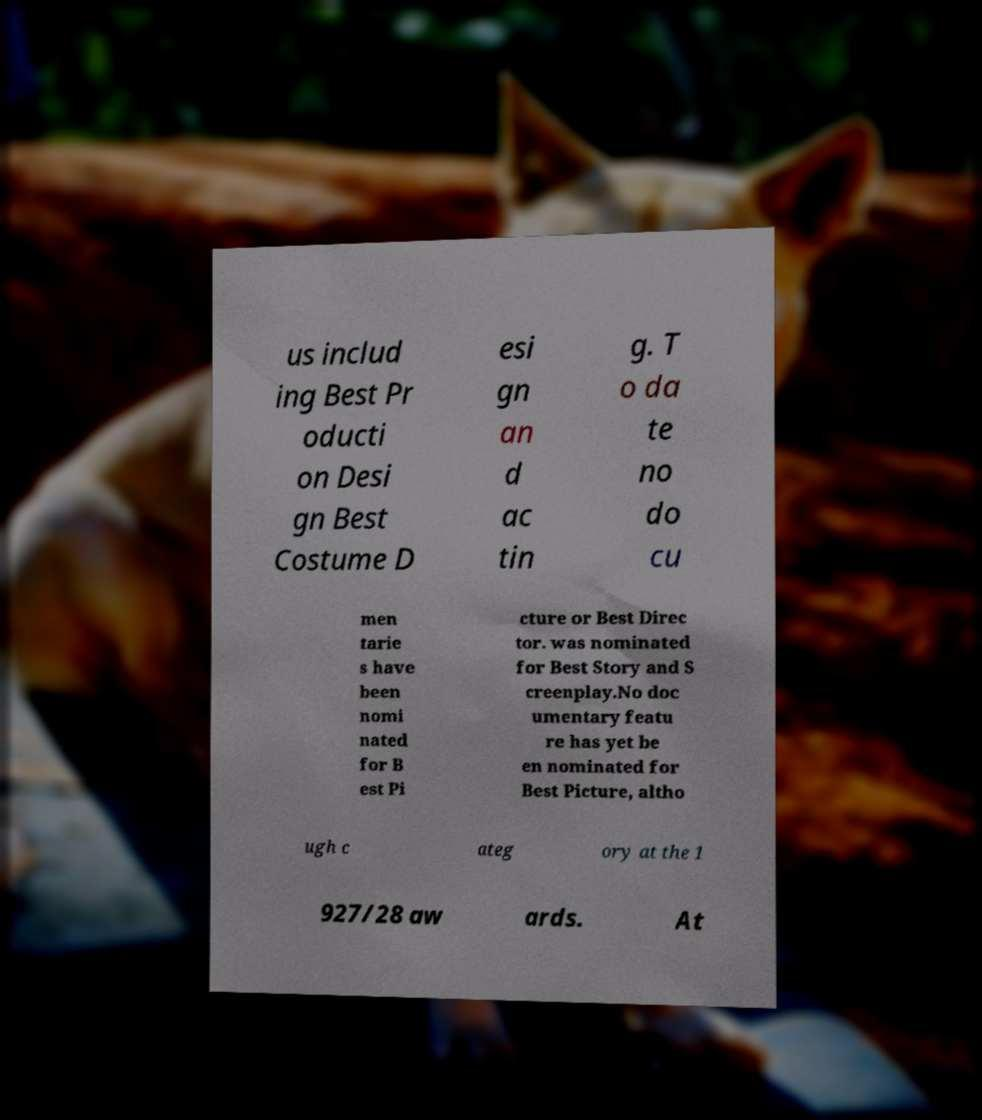Please read and relay the text visible in this image. What does it say? us includ ing Best Pr oducti on Desi gn Best Costume D esi gn an d ac tin g. T o da te no do cu men tarie s have been nomi nated for B est Pi cture or Best Direc tor. was nominated for Best Story and S creenplay.No doc umentary featu re has yet be en nominated for Best Picture, altho ugh c ateg ory at the 1 927/28 aw ards. At 